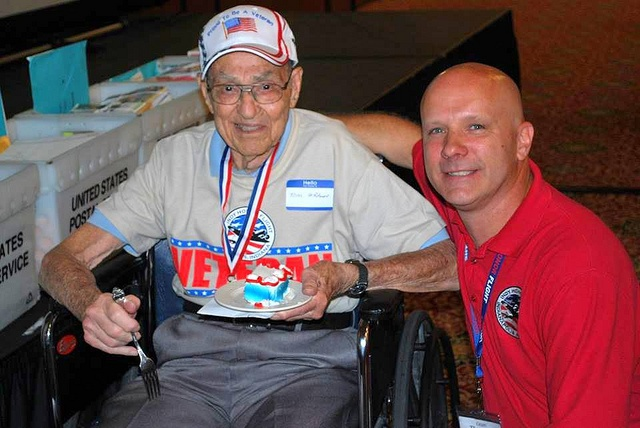Describe the objects in this image and their specific colors. I can see people in gray, lightgray, darkgray, and brown tones, people in gray, brown, and black tones, chair in gray, black, navy, and maroon tones, cake in gray, lightgray, and lightblue tones, and fork in gray, black, darkgray, and lightgray tones in this image. 